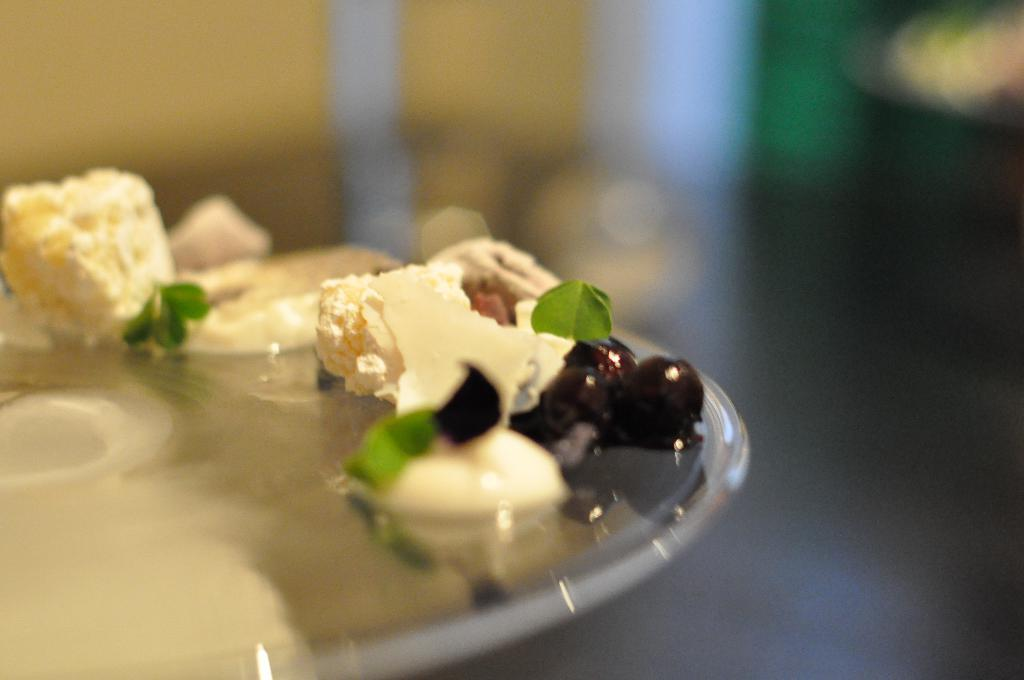What is on the plate in the image? There are fruits and sweets on the plate in the image. Can you describe the fruits on the plate? Unfortunately, the specific types of fruits cannot be determined from the image. What else is on the plate besides the fruits? There are sweets on the plate. Can you see a kitten swinging on a swing in the image? No, there is no kitten or swing present in the image. 